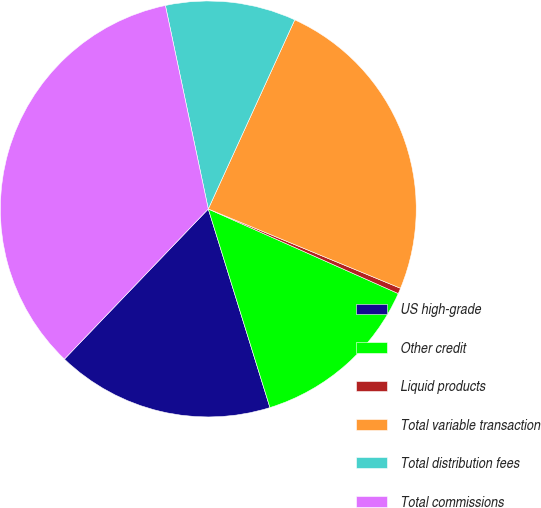Convert chart. <chart><loc_0><loc_0><loc_500><loc_500><pie_chart><fcel>US high-grade<fcel>Other credit<fcel>Liquid products<fcel>Total variable transaction<fcel>Total distribution fees<fcel>Total commissions<nl><fcel>16.95%<fcel>13.54%<fcel>0.44%<fcel>24.4%<fcel>10.13%<fcel>34.53%<nl></chart> 